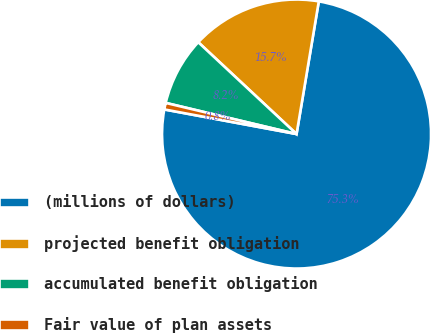Convert chart to OTSL. <chart><loc_0><loc_0><loc_500><loc_500><pie_chart><fcel>(millions of dollars)<fcel>projected benefit obligation<fcel>accumulated benefit obligation<fcel>Fair value of plan assets<nl><fcel>75.29%<fcel>15.69%<fcel>8.24%<fcel>0.79%<nl></chart> 